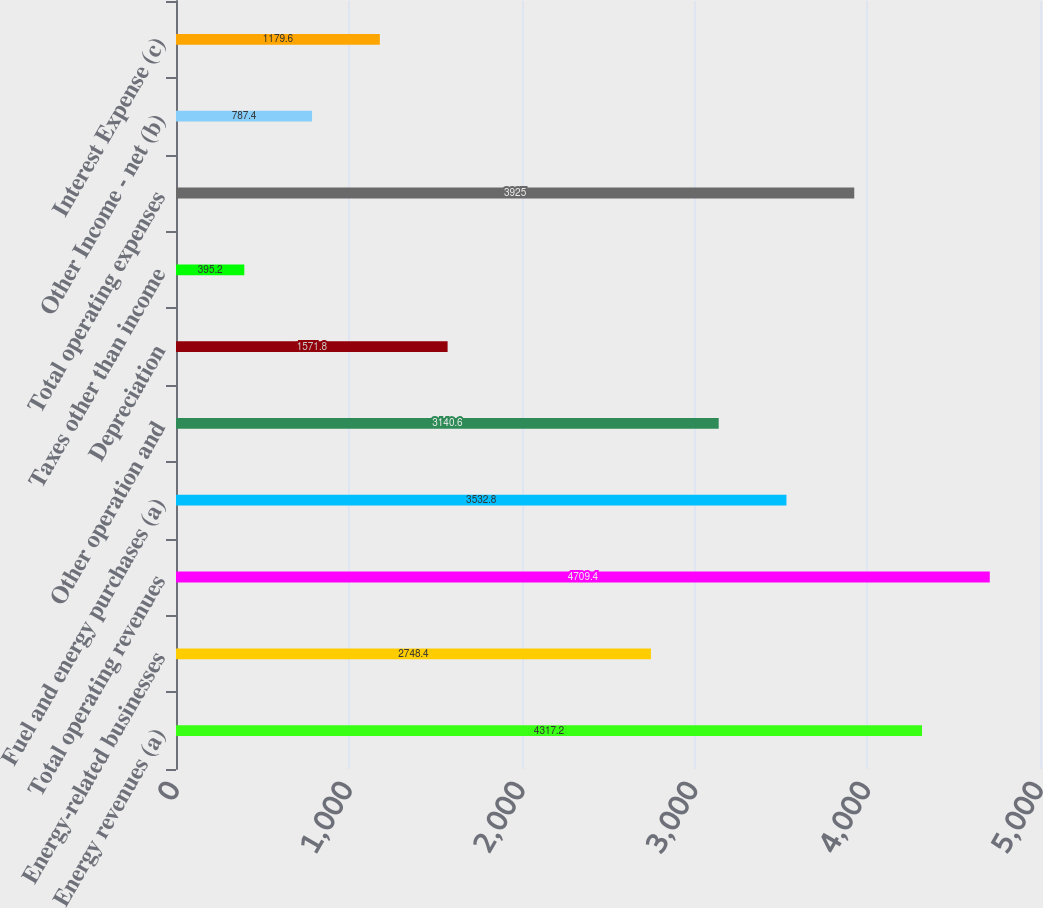Convert chart to OTSL. <chart><loc_0><loc_0><loc_500><loc_500><bar_chart><fcel>Energy revenues (a)<fcel>Energy-related businesses<fcel>Total operating revenues<fcel>Fuel and energy purchases (a)<fcel>Other operation and<fcel>Depreciation<fcel>Taxes other than income<fcel>Total operating expenses<fcel>Other Income - net (b)<fcel>Interest Expense (c)<nl><fcel>4317.2<fcel>2748.4<fcel>4709.4<fcel>3532.8<fcel>3140.6<fcel>1571.8<fcel>395.2<fcel>3925<fcel>787.4<fcel>1179.6<nl></chart> 